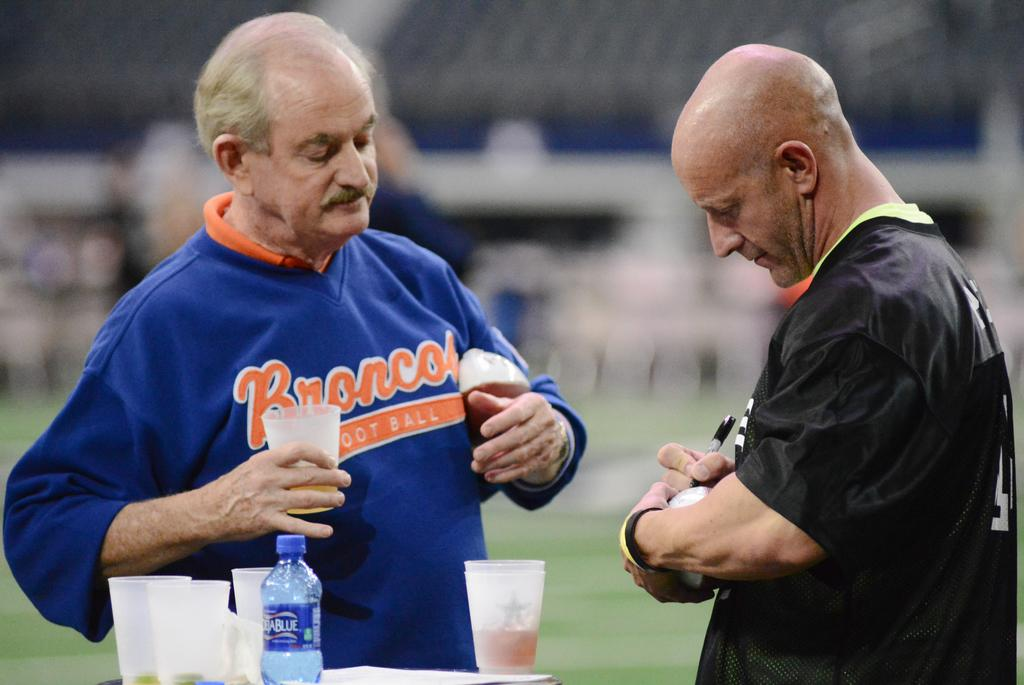How many people are in the image? There are two men in the image. What are the men doing in the image? The men are standing. What is present on the table in the image? There is a table in the image with glasses and a water bottle on it. What type of grain can be seen growing in the image? There is no grain present in the image; it features two men standing and a table with glasses and a water bottle. 